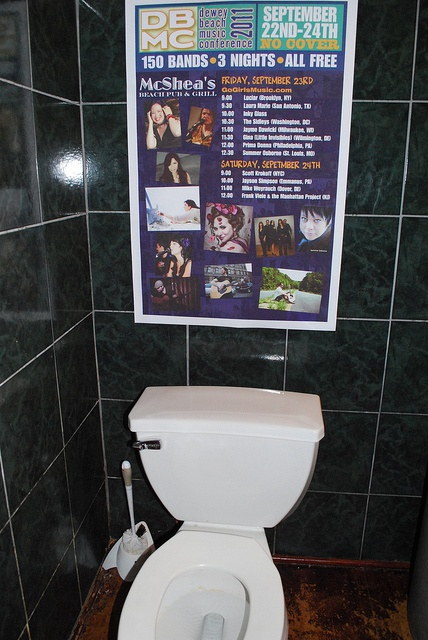Describe the objects in this image and their specific colors. I can see toilet in black, lightgray, and darkgray tones, people in black, tan, and gray tones, people in black, tan, and gray tones, and people in black, maroon, and brown tones in this image. 